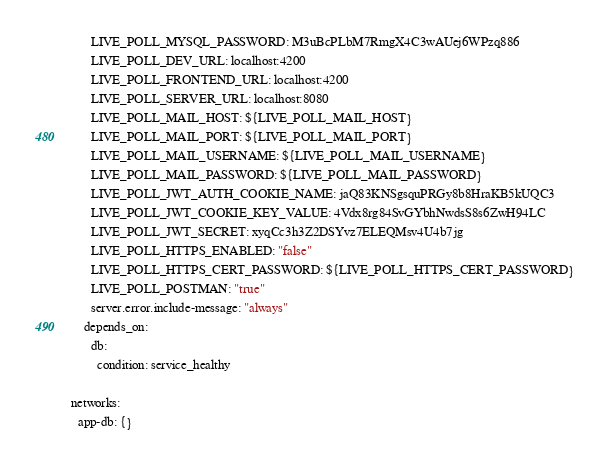<code> <loc_0><loc_0><loc_500><loc_500><_YAML_>      LIVE_POLL_MYSQL_PASSWORD: M3uBcPLbM7RmgX4C3wAUej6WPzq886
      LIVE_POLL_DEV_URL: localhost:4200
      LIVE_POLL_FRONTEND_URL: localhost:4200
      LIVE_POLL_SERVER_URL: localhost:8080
      LIVE_POLL_MAIL_HOST: ${LIVE_POLL_MAIL_HOST}
      LIVE_POLL_MAIL_PORT: ${LIVE_POLL_MAIL_PORT}
      LIVE_POLL_MAIL_USERNAME: ${LIVE_POLL_MAIL_USERNAME}
      LIVE_POLL_MAIL_PASSWORD: ${LIVE_POLL_MAIL_PASSWORD}
      LIVE_POLL_JWT_AUTH_COOKIE_NAME: jaQ83KNSgsquPRGy8b8HraKB5kUQC3
      LIVE_POLL_JWT_COOKIE_KEY_VALUE: 4Vdx8rg84SvGYbhNwdsS8s6ZwH94LC
      LIVE_POLL_JWT_SECRET: xyqCc3h3Z2DSYvz7ELEQMsv4U4b7jg
      LIVE_POLL_HTTPS_ENABLED: "false"
      LIVE_POLL_HTTPS_CERT_PASSWORD: ${LIVE_POLL_HTTPS_CERT_PASSWORD}
      LIVE_POLL_POSTMAN: "true"
      server.error.include-message: "always"
    depends_on:
      db:
        condition: service_healthy

networks:
  app-db: {}</code> 